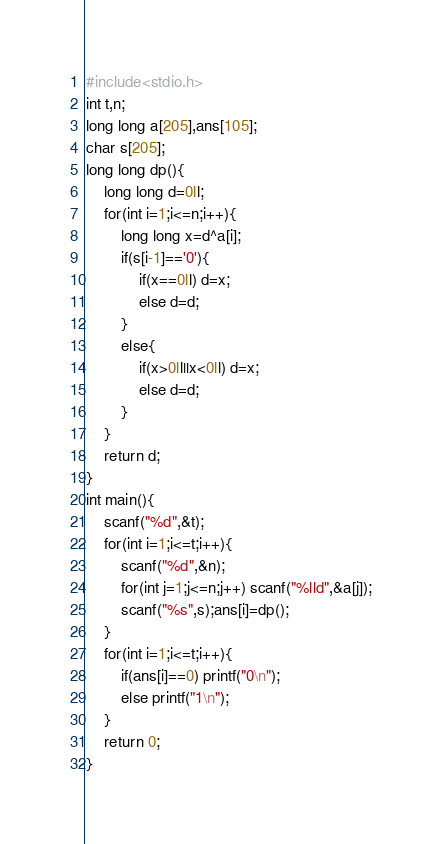Convert code to text. <code><loc_0><loc_0><loc_500><loc_500><_C++_>#include<stdio.h>
int t,n;
long long a[205],ans[105];
char s[205];
long long dp(){
	long long d=0ll;
	for(int i=1;i<=n;i++){
		long long x=d^a[i];
		if(s[i-1]=='0'){
			if(x==0ll) d=x;
			else d=d;
		}
		else{
			if(x>0ll||x<0ll) d=x;
			else d=d;
		}
	}
	return d;
}
int main(){
	scanf("%d",&t);
	for(int i=1;i<=t;i++){
		scanf("%d",&n);
		for(int j=1;j<=n;j++) scanf("%lld",&a[j]);
		scanf("%s",s);ans[i]=dp();
	}
	for(int i=1;i<=t;i++){
		if(ans[i]==0) printf("0\n");
		else printf("1\n");
	}
	return 0;
}</code> 